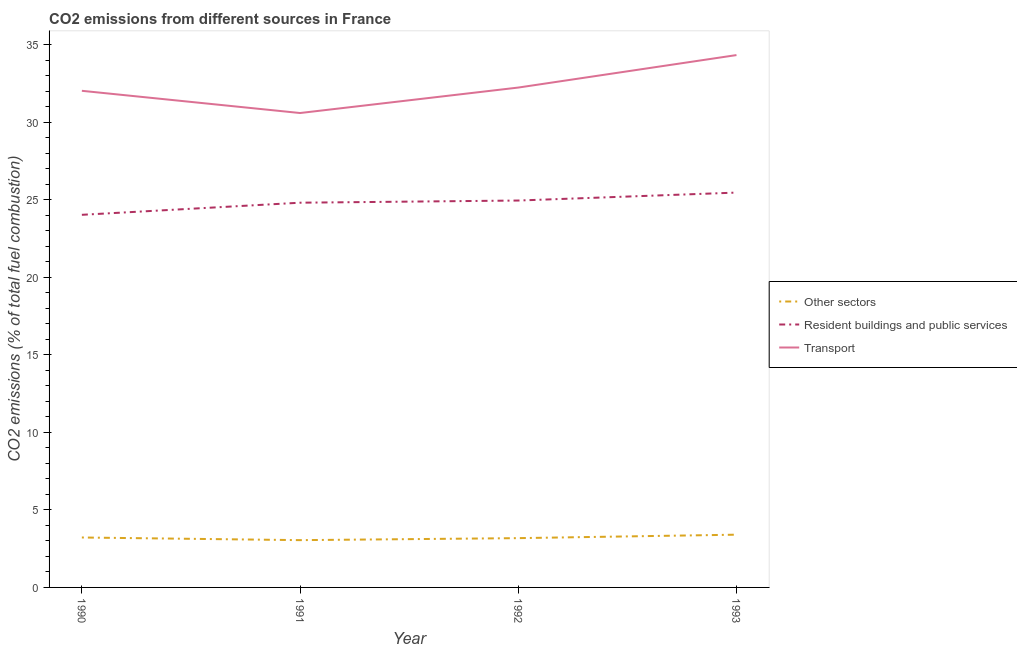What is the percentage of co2 emissions from other sectors in 1993?
Your response must be concise. 3.4. Across all years, what is the maximum percentage of co2 emissions from resident buildings and public services?
Keep it short and to the point. 25.46. Across all years, what is the minimum percentage of co2 emissions from transport?
Provide a short and direct response. 30.59. In which year was the percentage of co2 emissions from resident buildings and public services minimum?
Your answer should be compact. 1990. What is the total percentage of co2 emissions from other sectors in the graph?
Your answer should be very brief. 12.85. What is the difference between the percentage of co2 emissions from transport in 1990 and that in 1991?
Make the answer very short. 1.43. What is the difference between the percentage of co2 emissions from transport in 1990 and the percentage of co2 emissions from resident buildings and public services in 1991?
Your answer should be very brief. 7.21. What is the average percentage of co2 emissions from transport per year?
Provide a succinct answer. 32.29. In the year 1993, what is the difference between the percentage of co2 emissions from transport and percentage of co2 emissions from resident buildings and public services?
Offer a terse response. 8.87. In how many years, is the percentage of co2 emissions from transport greater than 17 %?
Offer a terse response. 4. What is the ratio of the percentage of co2 emissions from other sectors in 1990 to that in 1993?
Provide a short and direct response. 0.95. Is the percentage of co2 emissions from resident buildings and public services in 1990 less than that in 1993?
Provide a short and direct response. Yes. What is the difference between the highest and the second highest percentage of co2 emissions from transport?
Give a very brief answer. 2.09. What is the difference between the highest and the lowest percentage of co2 emissions from resident buildings and public services?
Provide a succinct answer. 1.43. How many years are there in the graph?
Your response must be concise. 4. Are the values on the major ticks of Y-axis written in scientific E-notation?
Offer a very short reply. No. Does the graph contain any zero values?
Make the answer very short. No. Does the graph contain grids?
Keep it short and to the point. No. Where does the legend appear in the graph?
Offer a terse response. Center right. How are the legend labels stacked?
Your response must be concise. Vertical. What is the title of the graph?
Keep it short and to the point. CO2 emissions from different sources in France. What is the label or title of the Y-axis?
Make the answer very short. CO2 emissions (% of total fuel combustion). What is the CO2 emissions (% of total fuel combustion) of Other sectors in 1990?
Make the answer very short. 3.22. What is the CO2 emissions (% of total fuel combustion) in Resident buildings and public services in 1990?
Provide a succinct answer. 24.03. What is the CO2 emissions (% of total fuel combustion) in Transport in 1990?
Offer a terse response. 32.02. What is the CO2 emissions (% of total fuel combustion) in Other sectors in 1991?
Offer a very short reply. 3.05. What is the CO2 emissions (% of total fuel combustion) in Resident buildings and public services in 1991?
Provide a succinct answer. 24.81. What is the CO2 emissions (% of total fuel combustion) in Transport in 1991?
Give a very brief answer. 30.59. What is the CO2 emissions (% of total fuel combustion) in Other sectors in 1992?
Your response must be concise. 3.18. What is the CO2 emissions (% of total fuel combustion) of Resident buildings and public services in 1992?
Offer a very short reply. 24.95. What is the CO2 emissions (% of total fuel combustion) in Transport in 1992?
Provide a succinct answer. 32.23. What is the CO2 emissions (% of total fuel combustion) of Other sectors in 1993?
Offer a very short reply. 3.4. What is the CO2 emissions (% of total fuel combustion) of Resident buildings and public services in 1993?
Your answer should be compact. 25.46. What is the CO2 emissions (% of total fuel combustion) of Transport in 1993?
Your response must be concise. 34.33. Across all years, what is the maximum CO2 emissions (% of total fuel combustion) in Other sectors?
Ensure brevity in your answer.  3.4. Across all years, what is the maximum CO2 emissions (% of total fuel combustion) of Resident buildings and public services?
Keep it short and to the point. 25.46. Across all years, what is the maximum CO2 emissions (% of total fuel combustion) of Transport?
Offer a very short reply. 34.33. Across all years, what is the minimum CO2 emissions (% of total fuel combustion) in Other sectors?
Your answer should be very brief. 3.05. Across all years, what is the minimum CO2 emissions (% of total fuel combustion) in Resident buildings and public services?
Make the answer very short. 24.03. Across all years, what is the minimum CO2 emissions (% of total fuel combustion) of Transport?
Your answer should be very brief. 30.59. What is the total CO2 emissions (% of total fuel combustion) in Other sectors in the graph?
Offer a terse response. 12.85. What is the total CO2 emissions (% of total fuel combustion) of Resident buildings and public services in the graph?
Make the answer very short. 99.24. What is the total CO2 emissions (% of total fuel combustion) of Transport in the graph?
Provide a short and direct response. 129.17. What is the difference between the CO2 emissions (% of total fuel combustion) in Other sectors in 1990 and that in 1991?
Your answer should be very brief. 0.17. What is the difference between the CO2 emissions (% of total fuel combustion) in Resident buildings and public services in 1990 and that in 1991?
Your response must be concise. -0.78. What is the difference between the CO2 emissions (% of total fuel combustion) of Transport in 1990 and that in 1991?
Provide a succinct answer. 1.43. What is the difference between the CO2 emissions (% of total fuel combustion) in Other sectors in 1990 and that in 1992?
Your answer should be compact. 0.04. What is the difference between the CO2 emissions (% of total fuel combustion) in Resident buildings and public services in 1990 and that in 1992?
Make the answer very short. -0.92. What is the difference between the CO2 emissions (% of total fuel combustion) of Transport in 1990 and that in 1992?
Offer a very short reply. -0.21. What is the difference between the CO2 emissions (% of total fuel combustion) in Other sectors in 1990 and that in 1993?
Ensure brevity in your answer.  -0.18. What is the difference between the CO2 emissions (% of total fuel combustion) in Resident buildings and public services in 1990 and that in 1993?
Provide a short and direct response. -1.43. What is the difference between the CO2 emissions (% of total fuel combustion) of Transport in 1990 and that in 1993?
Ensure brevity in your answer.  -2.3. What is the difference between the CO2 emissions (% of total fuel combustion) of Other sectors in 1991 and that in 1992?
Provide a succinct answer. -0.13. What is the difference between the CO2 emissions (% of total fuel combustion) in Resident buildings and public services in 1991 and that in 1992?
Your answer should be compact. -0.14. What is the difference between the CO2 emissions (% of total fuel combustion) in Transport in 1991 and that in 1992?
Offer a very short reply. -1.64. What is the difference between the CO2 emissions (% of total fuel combustion) in Other sectors in 1991 and that in 1993?
Your answer should be compact. -0.35. What is the difference between the CO2 emissions (% of total fuel combustion) of Resident buildings and public services in 1991 and that in 1993?
Make the answer very short. -0.65. What is the difference between the CO2 emissions (% of total fuel combustion) in Transport in 1991 and that in 1993?
Offer a terse response. -3.74. What is the difference between the CO2 emissions (% of total fuel combustion) of Other sectors in 1992 and that in 1993?
Ensure brevity in your answer.  -0.22. What is the difference between the CO2 emissions (% of total fuel combustion) in Resident buildings and public services in 1992 and that in 1993?
Provide a short and direct response. -0.51. What is the difference between the CO2 emissions (% of total fuel combustion) in Transport in 1992 and that in 1993?
Keep it short and to the point. -2.09. What is the difference between the CO2 emissions (% of total fuel combustion) of Other sectors in 1990 and the CO2 emissions (% of total fuel combustion) of Resident buildings and public services in 1991?
Offer a very short reply. -21.59. What is the difference between the CO2 emissions (% of total fuel combustion) in Other sectors in 1990 and the CO2 emissions (% of total fuel combustion) in Transport in 1991?
Ensure brevity in your answer.  -27.37. What is the difference between the CO2 emissions (% of total fuel combustion) in Resident buildings and public services in 1990 and the CO2 emissions (% of total fuel combustion) in Transport in 1991?
Your answer should be very brief. -6.56. What is the difference between the CO2 emissions (% of total fuel combustion) of Other sectors in 1990 and the CO2 emissions (% of total fuel combustion) of Resident buildings and public services in 1992?
Provide a short and direct response. -21.73. What is the difference between the CO2 emissions (% of total fuel combustion) of Other sectors in 1990 and the CO2 emissions (% of total fuel combustion) of Transport in 1992?
Offer a terse response. -29.01. What is the difference between the CO2 emissions (% of total fuel combustion) of Resident buildings and public services in 1990 and the CO2 emissions (% of total fuel combustion) of Transport in 1992?
Your answer should be compact. -8.21. What is the difference between the CO2 emissions (% of total fuel combustion) in Other sectors in 1990 and the CO2 emissions (% of total fuel combustion) in Resident buildings and public services in 1993?
Keep it short and to the point. -22.24. What is the difference between the CO2 emissions (% of total fuel combustion) in Other sectors in 1990 and the CO2 emissions (% of total fuel combustion) in Transport in 1993?
Offer a terse response. -31.11. What is the difference between the CO2 emissions (% of total fuel combustion) of Resident buildings and public services in 1990 and the CO2 emissions (% of total fuel combustion) of Transport in 1993?
Your answer should be compact. -10.3. What is the difference between the CO2 emissions (% of total fuel combustion) in Other sectors in 1991 and the CO2 emissions (% of total fuel combustion) in Resident buildings and public services in 1992?
Your answer should be very brief. -21.9. What is the difference between the CO2 emissions (% of total fuel combustion) in Other sectors in 1991 and the CO2 emissions (% of total fuel combustion) in Transport in 1992?
Give a very brief answer. -29.18. What is the difference between the CO2 emissions (% of total fuel combustion) of Resident buildings and public services in 1991 and the CO2 emissions (% of total fuel combustion) of Transport in 1992?
Offer a terse response. -7.42. What is the difference between the CO2 emissions (% of total fuel combustion) in Other sectors in 1991 and the CO2 emissions (% of total fuel combustion) in Resident buildings and public services in 1993?
Give a very brief answer. -22.41. What is the difference between the CO2 emissions (% of total fuel combustion) of Other sectors in 1991 and the CO2 emissions (% of total fuel combustion) of Transport in 1993?
Your response must be concise. -31.28. What is the difference between the CO2 emissions (% of total fuel combustion) of Resident buildings and public services in 1991 and the CO2 emissions (% of total fuel combustion) of Transport in 1993?
Your answer should be very brief. -9.52. What is the difference between the CO2 emissions (% of total fuel combustion) in Other sectors in 1992 and the CO2 emissions (% of total fuel combustion) in Resident buildings and public services in 1993?
Your answer should be very brief. -22.28. What is the difference between the CO2 emissions (% of total fuel combustion) in Other sectors in 1992 and the CO2 emissions (% of total fuel combustion) in Transport in 1993?
Ensure brevity in your answer.  -31.15. What is the difference between the CO2 emissions (% of total fuel combustion) in Resident buildings and public services in 1992 and the CO2 emissions (% of total fuel combustion) in Transport in 1993?
Offer a very short reply. -9.38. What is the average CO2 emissions (% of total fuel combustion) of Other sectors per year?
Offer a terse response. 3.21. What is the average CO2 emissions (% of total fuel combustion) of Resident buildings and public services per year?
Provide a succinct answer. 24.81. What is the average CO2 emissions (% of total fuel combustion) of Transport per year?
Offer a very short reply. 32.29. In the year 1990, what is the difference between the CO2 emissions (% of total fuel combustion) of Other sectors and CO2 emissions (% of total fuel combustion) of Resident buildings and public services?
Your answer should be compact. -20.81. In the year 1990, what is the difference between the CO2 emissions (% of total fuel combustion) of Other sectors and CO2 emissions (% of total fuel combustion) of Transport?
Your answer should be compact. -28.8. In the year 1990, what is the difference between the CO2 emissions (% of total fuel combustion) of Resident buildings and public services and CO2 emissions (% of total fuel combustion) of Transport?
Your answer should be very brief. -8. In the year 1991, what is the difference between the CO2 emissions (% of total fuel combustion) in Other sectors and CO2 emissions (% of total fuel combustion) in Resident buildings and public services?
Give a very brief answer. -21.76. In the year 1991, what is the difference between the CO2 emissions (% of total fuel combustion) in Other sectors and CO2 emissions (% of total fuel combustion) in Transport?
Provide a succinct answer. -27.54. In the year 1991, what is the difference between the CO2 emissions (% of total fuel combustion) in Resident buildings and public services and CO2 emissions (% of total fuel combustion) in Transport?
Your answer should be very brief. -5.78. In the year 1992, what is the difference between the CO2 emissions (% of total fuel combustion) in Other sectors and CO2 emissions (% of total fuel combustion) in Resident buildings and public services?
Make the answer very short. -21.77. In the year 1992, what is the difference between the CO2 emissions (% of total fuel combustion) of Other sectors and CO2 emissions (% of total fuel combustion) of Transport?
Give a very brief answer. -29.05. In the year 1992, what is the difference between the CO2 emissions (% of total fuel combustion) of Resident buildings and public services and CO2 emissions (% of total fuel combustion) of Transport?
Offer a terse response. -7.28. In the year 1993, what is the difference between the CO2 emissions (% of total fuel combustion) in Other sectors and CO2 emissions (% of total fuel combustion) in Resident buildings and public services?
Offer a very short reply. -22.06. In the year 1993, what is the difference between the CO2 emissions (% of total fuel combustion) in Other sectors and CO2 emissions (% of total fuel combustion) in Transport?
Offer a terse response. -30.93. In the year 1993, what is the difference between the CO2 emissions (% of total fuel combustion) in Resident buildings and public services and CO2 emissions (% of total fuel combustion) in Transport?
Your answer should be compact. -8.87. What is the ratio of the CO2 emissions (% of total fuel combustion) in Other sectors in 1990 to that in 1991?
Offer a very short reply. 1.06. What is the ratio of the CO2 emissions (% of total fuel combustion) of Resident buildings and public services in 1990 to that in 1991?
Keep it short and to the point. 0.97. What is the ratio of the CO2 emissions (% of total fuel combustion) in Transport in 1990 to that in 1991?
Your answer should be very brief. 1.05. What is the ratio of the CO2 emissions (% of total fuel combustion) of Other sectors in 1990 to that in 1992?
Keep it short and to the point. 1.01. What is the ratio of the CO2 emissions (% of total fuel combustion) of Resident buildings and public services in 1990 to that in 1992?
Provide a succinct answer. 0.96. What is the ratio of the CO2 emissions (% of total fuel combustion) of Other sectors in 1990 to that in 1993?
Give a very brief answer. 0.95. What is the ratio of the CO2 emissions (% of total fuel combustion) of Resident buildings and public services in 1990 to that in 1993?
Provide a short and direct response. 0.94. What is the ratio of the CO2 emissions (% of total fuel combustion) of Transport in 1990 to that in 1993?
Your answer should be very brief. 0.93. What is the ratio of the CO2 emissions (% of total fuel combustion) of Other sectors in 1991 to that in 1992?
Ensure brevity in your answer.  0.96. What is the ratio of the CO2 emissions (% of total fuel combustion) of Transport in 1991 to that in 1992?
Provide a short and direct response. 0.95. What is the ratio of the CO2 emissions (% of total fuel combustion) of Other sectors in 1991 to that in 1993?
Provide a succinct answer. 0.9. What is the ratio of the CO2 emissions (% of total fuel combustion) in Resident buildings and public services in 1991 to that in 1993?
Make the answer very short. 0.97. What is the ratio of the CO2 emissions (% of total fuel combustion) of Transport in 1991 to that in 1993?
Your answer should be very brief. 0.89. What is the ratio of the CO2 emissions (% of total fuel combustion) of Other sectors in 1992 to that in 1993?
Your response must be concise. 0.93. What is the ratio of the CO2 emissions (% of total fuel combustion) in Resident buildings and public services in 1992 to that in 1993?
Provide a succinct answer. 0.98. What is the ratio of the CO2 emissions (% of total fuel combustion) in Transport in 1992 to that in 1993?
Provide a succinct answer. 0.94. What is the difference between the highest and the second highest CO2 emissions (% of total fuel combustion) in Other sectors?
Offer a terse response. 0.18. What is the difference between the highest and the second highest CO2 emissions (% of total fuel combustion) in Resident buildings and public services?
Offer a terse response. 0.51. What is the difference between the highest and the second highest CO2 emissions (% of total fuel combustion) in Transport?
Offer a terse response. 2.09. What is the difference between the highest and the lowest CO2 emissions (% of total fuel combustion) in Other sectors?
Your response must be concise. 0.35. What is the difference between the highest and the lowest CO2 emissions (% of total fuel combustion) in Resident buildings and public services?
Provide a succinct answer. 1.43. What is the difference between the highest and the lowest CO2 emissions (% of total fuel combustion) in Transport?
Provide a short and direct response. 3.74. 